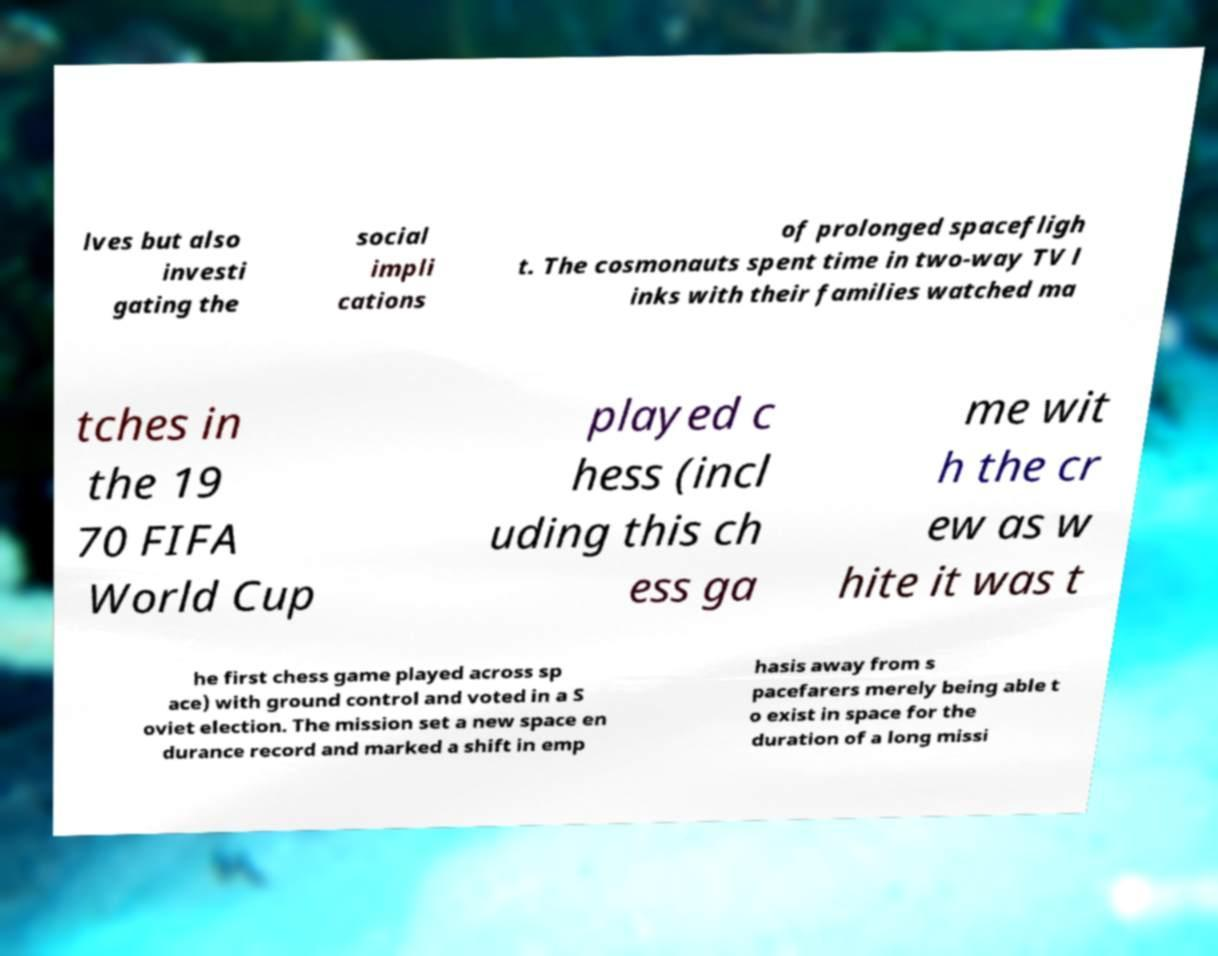Could you assist in decoding the text presented in this image and type it out clearly? lves but also investi gating the social impli cations of prolonged spacefligh t. The cosmonauts spent time in two-way TV l inks with their families watched ma tches in the 19 70 FIFA World Cup played c hess (incl uding this ch ess ga me wit h the cr ew as w hite it was t he first chess game played across sp ace) with ground control and voted in a S oviet election. The mission set a new space en durance record and marked a shift in emp hasis away from s pacefarers merely being able t o exist in space for the duration of a long missi 